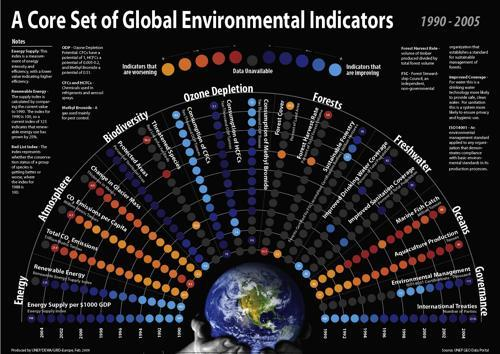What is the count of global environmental indicators?
Answer the question with a short phrase. 8 